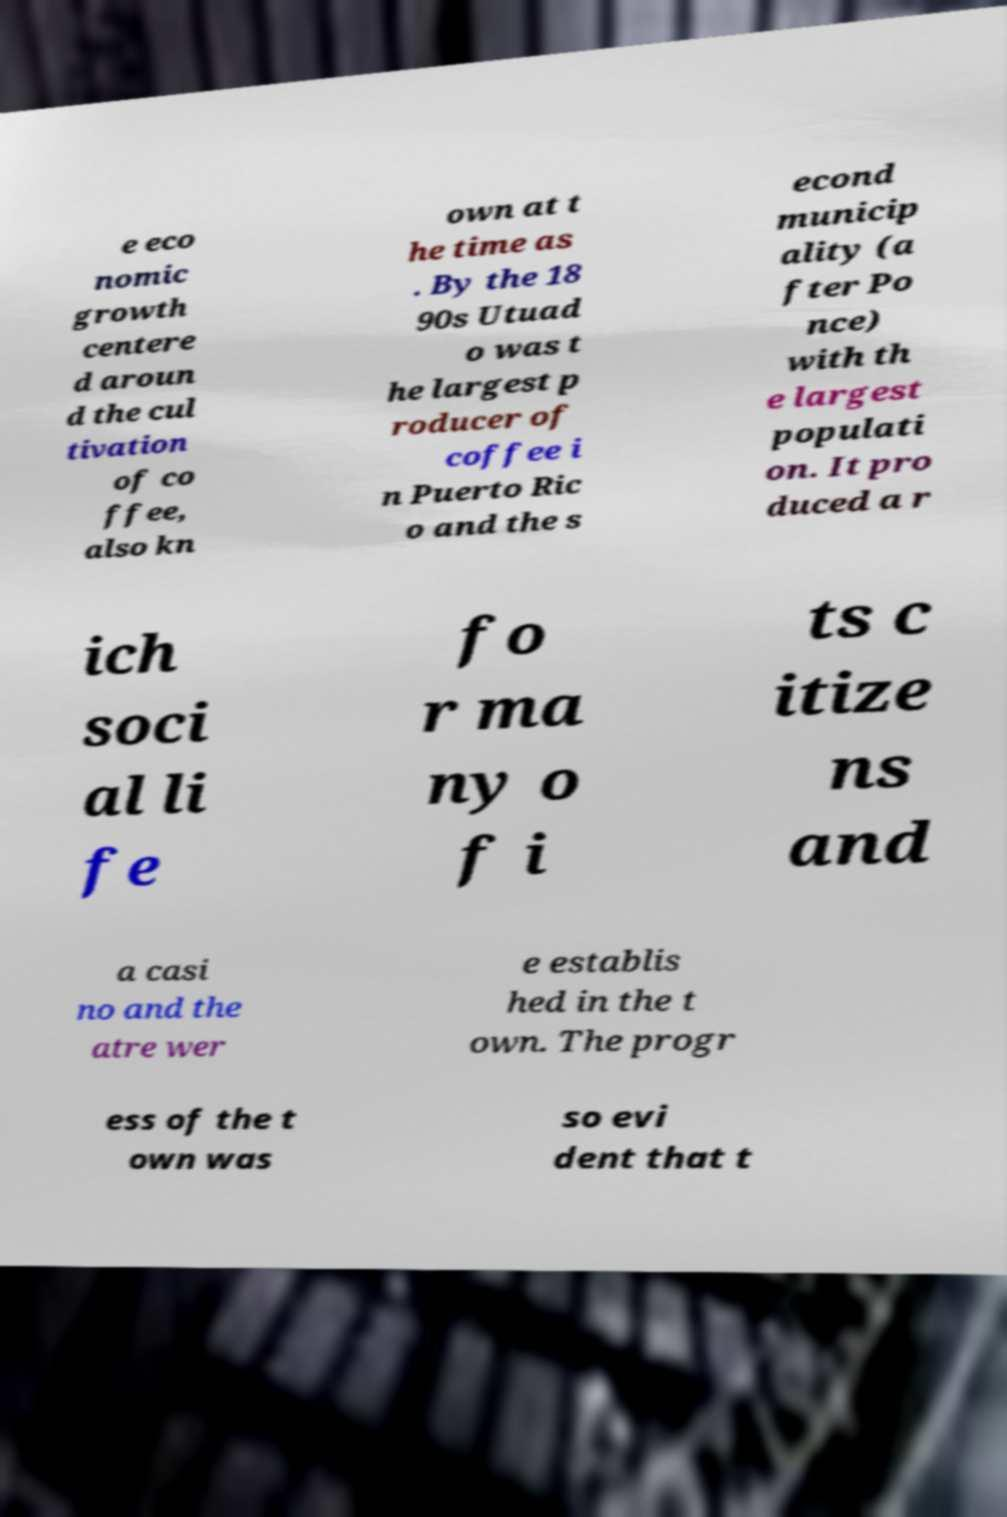For documentation purposes, I need the text within this image transcribed. Could you provide that? e eco nomic growth centere d aroun d the cul tivation of co ffee, also kn own at t he time as . By the 18 90s Utuad o was t he largest p roducer of coffee i n Puerto Ric o and the s econd municip ality (a fter Po nce) with th e largest populati on. It pro duced a r ich soci al li fe fo r ma ny o f i ts c itize ns and a casi no and the atre wer e establis hed in the t own. The progr ess of the t own was so evi dent that t 